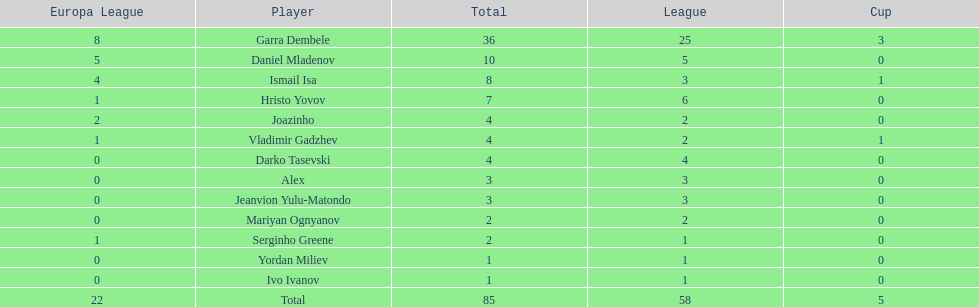What is the sum of the cup total and the europa league total? 27. 